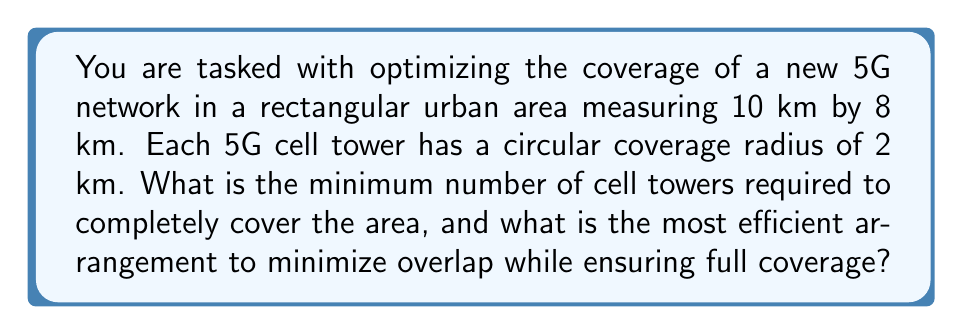Teach me how to tackle this problem. To solve this problem, we need to follow these steps:

1. Calculate the area of the rectangular urban region:
   $A_{rectangle} = 10 \text{ km} \times 8 \text{ km} = 80 \text{ km}^2$

2. Calculate the coverage area of a single cell tower:
   $A_{tower} = \pi r^2 = \pi \times 2^2 = 4\pi \text{ km}^2$

3. Determine the theoretical minimum number of towers needed:
   $N_{theoretical} = \frac{A_{rectangle}}{A_{tower}} = \frac{80}{4\pi} \approx 6.37$

   However, this doesn't account for overlap or edge effects.

4. Consider the most efficient packing arrangement:
   The most efficient way to cover a plane with circles is a hexagonal lattice arrangement. In this arrangement, the centers of the circles form equilateral triangles.

5. Calculate the area of the equilateral triangle formed by three adjacent tower centers:
   $A_{triangle} = \frac{\sqrt{3}}{4} \times (2\sqrt{3})^2 = 3\sqrt{3} \text{ km}^2$

6. Determine the number of equilateral triangles that fit in the rectangle:
   $N_{triangles} = \frac{A_{rectangle}}{A_{triangle}} = \frac{80}{3\sqrt{3}} \approx 15.4$

7. Calculate the number of tower centers:
   In a hexagonal lattice, each triangle vertex is shared by 6 triangles, so we divide by 3:
   $N_{towers} = \frac{N_{triangles}}{3} \times 3 + 2 \approx 17.4$

8. Round up to the nearest whole number:
   $N_{towers} = 18$

9. Arrange the towers:
   - Place 3 rows of 6 towers each
   - Offset the middle row by 1 km to create the hexagonal pattern

[asy]
unitsize(0.1cm);
for(int i=0; i<3; ++i)
  for(int j=0; j<6; ++j)
    filldraw(circle((j*200 + 100*(i%2), i*173), 20), white, black);
draw(box((0,0), (1000,520)));
label("10 km", (500,-20));
label("8 km", (1020,260), E);
[/asy]

This arrangement ensures complete coverage with minimal overlap while accounting for edge effects.
Answer: The minimum number of cell towers required is 18, arranged in 3 rows of 6 towers each, with the middle row offset to create a hexagonal lattice pattern. 